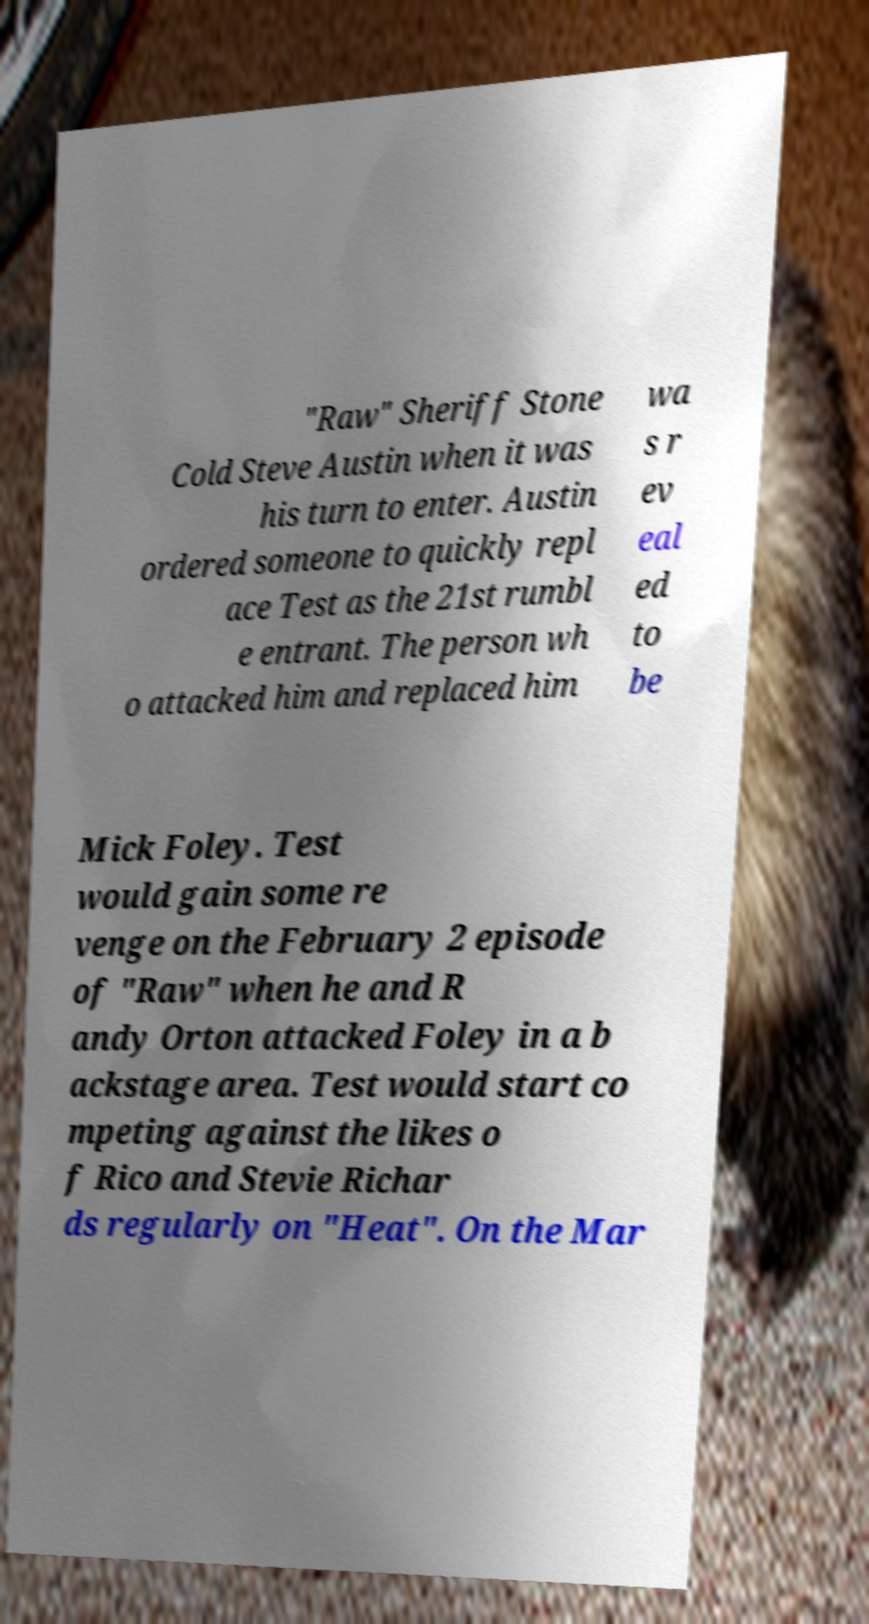What messages or text are displayed in this image? I need them in a readable, typed format. "Raw" Sheriff Stone Cold Steve Austin when it was his turn to enter. Austin ordered someone to quickly repl ace Test as the 21st rumbl e entrant. The person wh o attacked him and replaced him wa s r ev eal ed to be Mick Foley. Test would gain some re venge on the February 2 episode of "Raw" when he and R andy Orton attacked Foley in a b ackstage area. Test would start co mpeting against the likes o f Rico and Stevie Richar ds regularly on "Heat". On the Mar 